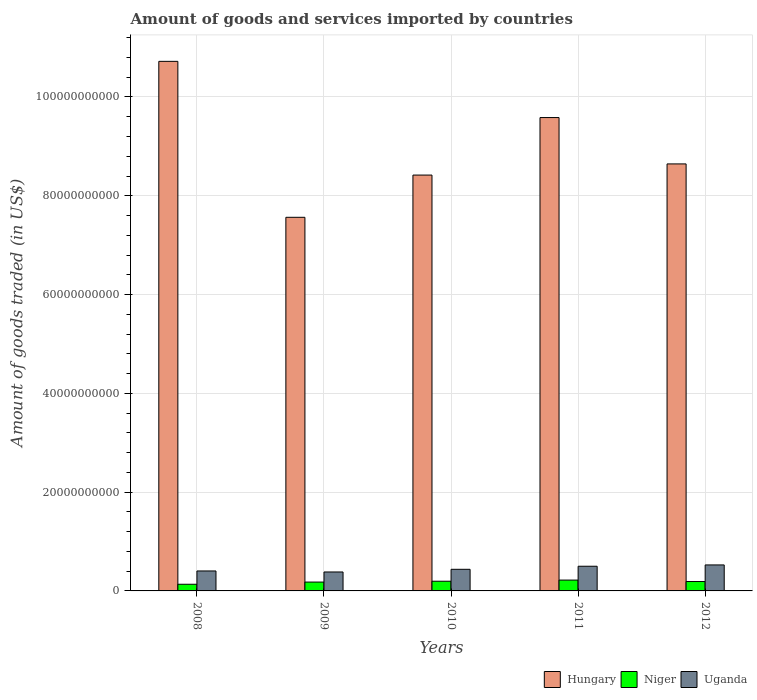How many different coloured bars are there?
Your answer should be compact. 3. Are the number of bars on each tick of the X-axis equal?
Your response must be concise. Yes. How many bars are there on the 3rd tick from the left?
Keep it short and to the point. 3. What is the label of the 2nd group of bars from the left?
Offer a very short reply. 2009. In how many cases, is the number of bars for a given year not equal to the number of legend labels?
Keep it short and to the point. 0. What is the total amount of goods and services imported in Uganda in 2009?
Your answer should be compact. 3.84e+09. Across all years, what is the maximum total amount of goods and services imported in Niger?
Ensure brevity in your answer.  2.19e+09. Across all years, what is the minimum total amount of goods and services imported in Niger?
Offer a terse response. 1.35e+09. In which year was the total amount of goods and services imported in Hungary minimum?
Your answer should be compact. 2009. What is the total total amount of goods and services imported in Hungary in the graph?
Provide a succinct answer. 4.49e+11. What is the difference between the total amount of goods and services imported in Uganda in 2011 and that in 2012?
Your answer should be compact. -2.65e+08. What is the difference between the total amount of goods and services imported in Niger in 2010 and the total amount of goods and services imported in Uganda in 2012?
Your answer should be compact. -3.30e+09. What is the average total amount of goods and services imported in Niger per year?
Your response must be concise. 1.84e+09. In the year 2008, what is the difference between the total amount of goods and services imported in Uganda and total amount of goods and services imported in Niger?
Provide a succinct answer. 2.69e+09. What is the ratio of the total amount of goods and services imported in Hungary in 2008 to that in 2010?
Ensure brevity in your answer.  1.27. Is the total amount of goods and services imported in Uganda in 2008 less than that in 2011?
Provide a short and direct response. Yes. Is the difference between the total amount of goods and services imported in Uganda in 2008 and 2012 greater than the difference between the total amount of goods and services imported in Niger in 2008 and 2012?
Make the answer very short. No. What is the difference between the highest and the second highest total amount of goods and services imported in Niger?
Provide a short and direct response. 2.30e+08. What is the difference between the highest and the lowest total amount of goods and services imported in Uganda?
Give a very brief answer. 1.43e+09. In how many years, is the total amount of goods and services imported in Niger greater than the average total amount of goods and services imported in Niger taken over all years?
Provide a succinct answer. 3. What does the 3rd bar from the left in 2011 represents?
Your answer should be compact. Uganda. What does the 3rd bar from the right in 2012 represents?
Provide a short and direct response. Hungary. Is it the case that in every year, the sum of the total amount of goods and services imported in Uganda and total amount of goods and services imported in Hungary is greater than the total amount of goods and services imported in Niger?
Your answer should be very brief. Yes. How many years are there in the graph?
Give a very brief answer. 5. Are the values on the major ticks of Y-axis written in scientific E-notation?
Offer a very short reply. No. How are the legend labels stacked?
Make the answer very short. Horizontal. What is the title of the graph?
Your response must be concise. Amount of goods and services imported by countries. Does "Malawi" appear as one of the legend labels in the graph?
Offer a terse response. No. What is the label or title of the X-axis?
Provide a succinct answer. Years. What is the label or title of the Y-axis?
Your response must be concise. Amount of goods traded (in US$). What is the Amount of goods traded (in US$) of Hungary in 2008?
Your answer should be compact. 1.07e+11. What is the Amount of goods traded (in US$) in Niger in 2008?
Offer a very short reply. 1.35e+09. What is the Amount of goods traded (in US$) of Uganda in 2008?
Ensure brevity in your answer.  4.04e+09. What is the Amount of goods traded (in US$) in Hungary in 2009?
Make the answer very short. 7.56e+1. What is the Amount of goods traded (in US$) in Niger in 2009?
Your answer should be very brief. 1.79e+09. What is the Amount of goods traded (in US$) in Uganda in 2009?
Offer a very short reply. 3.84e+09. What is the Amount of goods traded (in US$) of Hungary in 2010?
Your response must be concise. 8.42e+1. What is the Amount of goods traded (in US$) in Niger in 2010?
Offer a very short reply. 1.96e+09. What is the Amount of goods traded (in US$) in Uganda in 2010?
Offer a very short reply. 4.38e+09. What is the Amount of goods traded (in US$) of Hungary in 2011?
Provide a succinct answer. 9.58e+1. What is the Amount of goods traded (in US$) of Niger in 2011?
Provide a succinct answer. 2.19e+09. What is the Amount of goods traded (in US$) in Uganda in 2011?
Keep it short and to the point. 5.00e+09. What is the Amount of goods traded (in US$) of Hungary in 2012?
Your answer should be very brief. 8.65e+1. What is the Amount of goods traded (in US$) of Niger in 2012?
Your answer should be compact. 1.90e+09. What is the Amount of goods traded (in US$) of Uganda in 2012?
Provide a short and direct response. 5.26e+09. Across all years, what is the maximum Amount of goods traded (in US$) in Hungary?
Offer a terse response. 1.07e+11. Across all years, what is the maximum Amount of goods traded (in US$) in Niger?
Keep it short and to the point. 2.19e+09. Across all years, what is the maximum Amount of goods traded (in US$) of Uganda?
Make the answer very short. 5.26e+09. Across all years, what is the minimum Amount of goods traded (in US$) of Hungary?
Provide a short and direct response. 7.56e+1. Across all years, what is the minimum Amount of goods traded (in US$) in Niger?
Offer a terse response. 1.35e+09. Across all years, what is the minimum Amount of goods traded (in US$) in Uganda?
Offer a very short reply. 3.84e+09. What is the total Amount of goods traded (in US$) of Hungary in the graph?
Keep it short and to the point. 4.49e+11. What is the total Amount of goods traded (in US$) in Niger in the graph?
Your answer should be compact. 9.20e+09. What is the total Amount of goods traded (in US$) of Uganda in the graph?
Ensure brevity in your answer.  2.25e+1. What is the difference between the Amount of goods traded (in US$) in Hungary in 2008 and that in 2009?
Your response must be concise. 3.16e+1. What is the difference between the Amount of goods traded (in US$) of Niger in 2008 and that in 2009?
Offer a very short reply. -4.44e+08. What is the difference between the Amount of goods traded (in US$) in Uganda in 2008 and that in 2009?
Offer a terse response. 2.08e+08. What is the difference between the Amount of goods traded (in US$) in Hungary in 2008 and that in 2010?
Offer a terse response. 2.30e+1. What is the difference between the Amount of goods traded (in US$) in Niger in 2008 and that in 2010?
Your response must be concise. -6.13e+08. What is the difference between the Amount of goods traded (in US$) of Uganda in 2008 and that in 2010?
Keep it short and to the point. -3.33e+08. What is the difference between the Amount of goods traded (in US$) of Hungary in 2008 and that in 2011?
Make the answer very short. 1.14e+1. What is the difference between the Amount of goods traded (in US$) in Niger in 2008 and that in 2011?
Your answer should be very brief. -8.43e+08. What is the difference between the Amount of goods traded (in US$) of Uganda in 2008 and that in 2011?
Give a very brief answer. -9.54e+08. What is the difference between the Amount of goods traded (in US$) in Hungary in 2008 and that in 2012?
Provide a short and direct response. 2.08e+1. What is the difference between the Amount of goods traded (in US$) in Niger in 2008 and that in 2012?
Ensure brevity in your answer.  -5.54e+08. What is the difference between the Amount of goods traded (in US$) in Uganda in 2008 and that in 2012?
Keep it short and to the point. -1.22e+09. What is the difference between the Amount of goods traded (in US$) of Hungary in 2009 and that in 2010?
Offer a terse response. -8.55e+09. What is the difference between the Amount of goods traded (in US$) of Niger in 2009 and that in 2010?
Make the answer very short. -1.69e+08. What is the difference between the Amount of goods traded (in US$) of Uganda in 2009 and that in 2010?
Offer a terse response. -5.40e+08. What is the difference between the Amount of goods traded (in US$) in Hungary in 2009 and that in 2011?
Your response must be concise. -2.02e+1. What is the difference between the Amount of goods traded (in US$) of Niger in 2009 and that in 2011?
Provide a succinct answer. -3.99e+08. What is the difference between the Amount of goods traded (in US$) in Uganda in 2009 and that in 2011?
Provide a short and direct response. -1.16e+09. What is the difference between the Amount of goods traded (in US$) of Hungary in 2009 and that in 2012?
Provide a short and direct response. -1.08e+1. What is the difference between the Amount of goods traded (in US$) of Niger in 2009 and that in 2012?
Make the answer very short. -1.10e+08. What is the difference between the Amount of goods traded (in US$) of Uganda in 2009 and that in 2012?
Ensure brevity in your answer.  -1.43e+09. What is the difference between the Amount of goods traded (in US$) in Hungary in 2010 and that in 2011?
Provide a succinct answer. -1.16e+1. What is the difference between the Amount of goods traded (in US$) of Niger in 2010 and that in 2011?
Provide a short and direct response. -2.30e+08. What is the difference between the Amount of goods traded (in US$) of Uganda in 2010 and that in 2011?
Provide a short and direct response. -6.21e+08. What is the difference between the Amount of goods traded (in US$) of Hungary in 2010 and that in 2012?
Offer a terse response. -2.26e+09. What is the difference between the Amount of goods traded (in US$) of Niger in 2010 and that in 2012?
Ensure brevity in your answer.  5.96e+07. What is the difference between the Amount of goods traded (in US$) of Uganda in 2010 and that in 2012?
Your response must be concise. -8.86e+08. What is the difference between the Amount of goods traded (in US$) in Hungary in 2011 and that in 2012?
Provide a succinct answer. 9.39e+09. What is the difference between the Amount of goods traded (in US$) in Niger in 2011 and that in 2012?
Provide a short and direct response. 2.89e+08. What is the difference between the Amount of goods traded (in US$) in Uganda in 2011 and that in 2012?
Provide a short and direct response. -2.65e+08. What is the difference between the Amount of goods traded (in US$) of Hungary in 2008 and the Amount of goods traded (in US$) of Niger in 2009?
Offer a terse response. 1.05e+11. What is the difference between the Amount of goods traded (in US$) in Hungary in 2008 and the Amount of goods traded (in US$) in Uganda in 2009?
Provide a succinct answer. 1.03e+11. What is the difference between the Amount of goods traded (in US$) in Niger in 2008 and the Amount of goods traded (in US$) in Uganda in 2009?
Provide a succinct answer. -2.49e+09. What is the difference between the Amount of goods traded (in US$) of Hungary in 2008 and the Amount of goods traded (in US$) of Niger in 2010?
Make the answer very short. 1.05e+11. What is the difference between the Amount of goods traded (in US$) in Hungary in 2008 and the Amount of goods traded (in US$) in Uganda in 2010?
Make the answer very short. 1.03e+11. What is the difference between the Amount of goods traded (in US$) in Niger in 2008 and the Amount of goods traded (in US$) in Uganda in 2010?
Offer a very short reply. -3.03e+09. What is the difference between the Amount of goods traded (in US$) in Hungary in 2008 and the Amount of goods traded (in US$) in Niger in 2011?
Your answer should be compact. 1.05e+11. What is the difference between the Amount of goods traded (in US$) of Hungary in 2008 and the Amount of goods traded (in US$) of Uganda in 2011?
Ensure brevity in your answer.  1.02e+11. What is the difference between the Amount of goods traded (in US$) of Niger in 2008 and the Amount of goods traded (in US$) of Uganda in 2011?
Offer a terse response. -3.65e+09. What is the difference between the Amount of goods traded (in US$) in Hungary in 2008 and the Amount of goods traded (in US$) in Niger in 2012?
Your answer should be compact. 1.05e+11. What is the difference between the Amount of goods traded (in US$) of Hungary in 2008 and the Amount of goods traded (in US$) of Uganda in 2012?
Offer a very short reply. 1.02e+11. What is the difference between the Amount of goods traded (in US$) in Niger in 2008 and the Amount of goods traded (in US$) in Uganda in 2012?
Provide a short and direct response. -3.91e+09. What is the difference between the Amount of goods traded (in US$) of Hungary in 2009 and the Amount of goods traded (in US$) of Niger in 2010?
Your answer should be very brief. 7.37e+1. What is the difference between the Amount of goods traded (in US$) in Hungary in 2009 and the Amount of goods traded (in US$) in Uganda in 2010?
Your answer should be very brief. 7.13e+1. What is the difference between the Amount of goods traded (in US$) in Niger in 2009 and the Amount of goods traded (in US$) in Uganda in 2010?
Keep it short and to the point. -2.58e+09. What is the difference between the Amount of goods traded (in US$) of Hungary in 2009 and the Amount of goods traded (in US$) of Niger in 2011?
Offer a terse response. 7.34e+1. What is the difference between the Amount of goods traded (in US$) in Hungary in 2009 and the Amount of goods traded (in US$) in Uganda in 2011?
Provide a succinct answer. 7.06e+1. What is the difference between the Amount of goods traded (in US$) of Niger in 2009 and the Amount of goods traded (in US$) of Uganda in 2011?
Provide a succinct answer. -3.20e+09. What is the difference between the Amount of goods traded (in US$) in Hungary in 2009 and the Amount of goods traded (in US$) in Niger in 2012?
Provide a short and direct response. 7.37e+1. What is the difference between the Amount of goods traded (in US$) in Hungary in 2009 and the Amount of goods traded (in US$) in Uganda in 2012?
Give a very brief answer. 7.04e+1. What is the difference between the Amount of goods traded (in US$) of Niger in 2009 and the Amount of goods traded (in US$) of Uganda in 2012?
Keep it short and to the point. -3.47e+09. What is the difference between the Amount of goods traded (in US$) in Hungary in 2010 and the Amount of goods traded (in US$) in Niger in 2011?
Keep it short and to the point. 8.20e+1. What is the difference between the Amount of goods traded (in US$) of Hungary in 2010 and the Amount of goods traded (in US$) of Uganda in 2011?
Make the answer very short. 7.92e+1. What is the difference between the Amount of goods traded (in US$) of Niger in 2010 and the Amount of goods traded (in US$) of Uganda in 2011?
Keep it short and to the point. -3.03e+09. What is the difference between the Amount of goods traded (in US$) in Hungary in 2010 and the Amount of goods traded (in US$) in Niger in 2012?
Provide a short and direct response. 8.23e+1. What is the difference between the Amount of goods traded (in US$) of Hungary in 2010 and the Amount of goods traded (in US$) of Uganda in 2012?
Provide a short and direct response. 7.89e+1. What is the difference between the Amount of goods traded (in US$) in Niger in 2010 and the Amount of goods traded (in US$) in Uganda in 2012?
Make the answer very short. -3.30e+09. What is the difference between the Amount of goods traded (in US$) in Hungary in 2011 and the Amount of goods traded (in US$) in Niger in 2012?
Your answer should be compact. 9.39e+1. What is the difference between the Amount of goods traded (in US$) in Hungary in 2011 and the Amount of goods traded (in US$) in Uganda in 2012?
Keep it short and to the point. 9.06e+1. What is the difference between the Amount of goods traded (in US$) in Niger in 2011 and the Amount of goods traded (in US$) in Uganda in 2012?
Your answer should be very brief. -3.07e+09. What is the average Amount of goods traded (in US$) in Hungary per year?
Provide a succinct answer. 8.99e+1. What is the average Amount of goods traded (in US$) in Niger per year?
Offer a terse response. 1.84e+09. What is the average Amount of goods traded (in US$) in Uganda per year?
Provide a short and direct response. 4.50e+09. In the year 2008, what is the difference between the Amount of goods traded (in US$) of Hungary and Amount of goods traded (in US$) of Niger?
Keep it short and to the point. 1.06e+11. In the year 2008, what is the difference between the Amount of goods traded (in US$) in Hungary and Amount of goods traded (in US$) in Uganda?
Your answer should be compact. 1.03e+11. In the year 2008, what is the difference between the Amount of goods traded (in US$) in Niger and Amount of goods traded (in US$) in Uganda?
Your answer should be very brief. -2.69e+09. In the year 2009, what is the difference between the Amount of goods traded (in US$) of Hungary and Amount of goods traded (in US$) of Niger?
Your answer should be compact. 7.38e+1. In the year 2009, what is the difference between the Amount of goods traded (in US$) in Hungary and Amount of goods traded (in US$) in Uganda?
Give a very brief answer. 7.18e+1. In the year 2009, what is the difference between the Amount of goods traded (in US$) of Niger and Amount of goods traded (in US$) of Uganda?
Make the answer very short. -2.04e+09. In the year 2010, what is the difference between the Amount of goods traded (in US$) in Hungary and Amount of goods traded (in US$) in Niger?
Keep it short and to the point. 8.22e+1. In the year 2010, what is the difference between the Amount of goods traded (in US$) in Hungary and Amount of goods traded (in US$) in Uganda?
Ensure brevity in your answer.  7.98e+1. In the year 2010, what is the difference between the Amount of goods traded (in US$) in Niger and Amount of goods traded (in US$) in Uganda?
Offer a terse response. -2.41e+09. In the year 2011, what is the difference between the Amount of goods traded (in US$) in Hungary and Amount of goods traded (in US$) in Niger?
Offer a terse response. 9.36e+1. In the year 2011, what is the difference between the Amount of goods traded (in US$) in Hungary and Amount of goods traded (in US$) in Uganda?
Give a very brief answer. 9.08e+1. In the year 2011, what is the difference between the Amount of goods traded (in US$) in Niger and Amount of goods traded (in US$) in Uganda?
Make the answer very short. -2.80e+09. In the year 2012, what is the difference between the Amount of goods traded (in US$) in Hungary and Amount of goods traded (in US$) in Niger?
Your answer should be very brief. 8.45e+1. In the year 2012, what is the difference between the Amount of goods traded (in US$) in Hungary and Amount of goods traded (in US$) in Uganda?
Offer a terse response. 8.12e+1. In the year 2012, what is the difference between the Amount of goods traded (in US$) of Niger and Amount of goods traded (in US$) of Uganda?
Provide a succinct answer. -3.36e+09. What is the ratio of the Amount of goods traded (in US$) of Hungary in 2008 to that in 2009?
Your answer should be compact. 1.42. What is the ratio of the Amount of goods traded (in US$) in Niger in 2008 to that in 2009?
Your answer should be very brief. 0.75. What is the ratio of the Amount of goods traded (in US$) of Uganda in 2008 to that in 2009?
Offer a terse response. 1.05. What is the ratio of the Amount of goods traded (in US$) of Hungary in 2008 to that in 2010?
Your answer should be compact. 1.27. What is the ratio of the Amount of goods traded (in US$) in Niger in 2008 to that in 2010?
Provide a succinct answer. 0.69. What is the ratio of the Amount of goods traded (in US$) of Uganda in 2008 to that in 2010?
Make the answer very short. 0.92. What is the ratio of the Amount of goods traded (in US$) in Hungary in 2008 to that in 2011?
Your answer should be very brief. 1.12. What is the ratio of the Amount of goods traded (in US$) of Niger in 2008 to that in 2011?
Make the answer very short. 0.62. What is the ratio of the Amount of goods traded (in US$) in Uganda in 2008 to that in 2011?
Your answer should be very brief. 0.81. What is the ratio of the Amount of goods traded (in US$) in Hungary in 2008 to that in 2012?
Make the answer very short. 1.24. What is the ratio of the Amount of goods traded (in US$) of Niger in 2008 to that in 2012?
Give a very brief answer. 0.71. What is the ratio of the Amount of goods traded (in US$) in Uganda in 2008 to that in 2012?
Give a very brief answer. 0.77. What is the ratio of the Amount of goods traded (in US$) of Hungary in 2009 to that in 2010?
Your answer should be compact. 0.9. What is the ratio of the Amount of goods traded (in US$) of Niger in 2009 to that in 2010?
Your answer should be very brief. 0.91. What is the ratio of the Amount of goods traded (in US$) in Uganda in 2009 to that in 2010?
Provide a short and direct response. 0.88. What is the ratio of the Amount of goods traded (in US$) of Hungary in 2009 to that in 2011?
Offer a terse response. 0.79. What is the ratio of the Amount of goods traded (in US$) in Niger in 2009 to that in 2011?
Provide a short and direct response. 0.82. What is the ratio of the Amount of goods traded (in US$) of Uganda in 2009 to that in 2011?
Make the answer very short. 0.77. What is the ratio of the Amount of goods traded (in US$) in Niger in 2009 to that in 2012?
Offer a very short reply. 0.94. What is the ratio of the Amount of goods traded (in US$) in Uganda in 2009 to that in 2012?
Provide a succinct answer. 0.73. What is the ratio of the Amount of goods traded (in US$) of Hungary in 2010 to that in 2011?
Provide a succinct answer. 0.88. What is the ratio of the Amount of goods traded (in US$) of Niger in 2010 to that in 2011?
Your answer should be very brief. 0.9. What is the ratio of the Amount of goods traded (in US$) in Uganda in 2010 to that in 2011?
Provide a succinct answer. 0.88. What is the ratio of the Amount of goods traded (in US$) in Hungary in 2010 to that in 2012?
Your response must be concise. 0.97. What is the ratio of the Amount of goods traded (in US$) of Niger in 2010 to that in 2012?
Keep it short and to the point. 1.03. What is the ratio of the Amount of goods traded (in US$) in Uganda in 2010 to that in 2012?
Your response must be concise. 0.83. What is the ratio of the Amount of goods traded (in US$) in Hungary in 2011 to that in 2012?
Provide a succinct answer. 1.11. What is the ratio of the Amount of goods traded (in US$) in Niger in 2011 to that in 2012?
Offer a very short reply. 1.15. What is the ratio of the Amount of goods traded (in US$) in Uganda in 2011 to that in 2012?
Keep it short and to the point. 0.95. What is the difference between the highest and the second highest Amount of goods traded (in US$) of Hungary?
Offer a terse response. 1.14e+1. What is the difference between the highest and the second highest Amount of goods traded (in US$) of Niger?
Offer a very short reply. 2.30e+08. What is the difference between the highest and the second highest Amount of goods traded (in US$) in Uganda?
Provide a short and direct response. 2.65e+08. What is the difference between the highest and the lowest Amount of goods traded (in US$) in Hungary?
Offer a terse response. 3.16e+1. What is the difference between the highest and the lowest Amount of goods traded (in US$) in Niger?
Make the answer very short. 8.43e+08. What is the difference between the highest and the lowest Amount of goods traded (in US$) of Uganda?
Keep it short and to the point. 1.43e+09. 